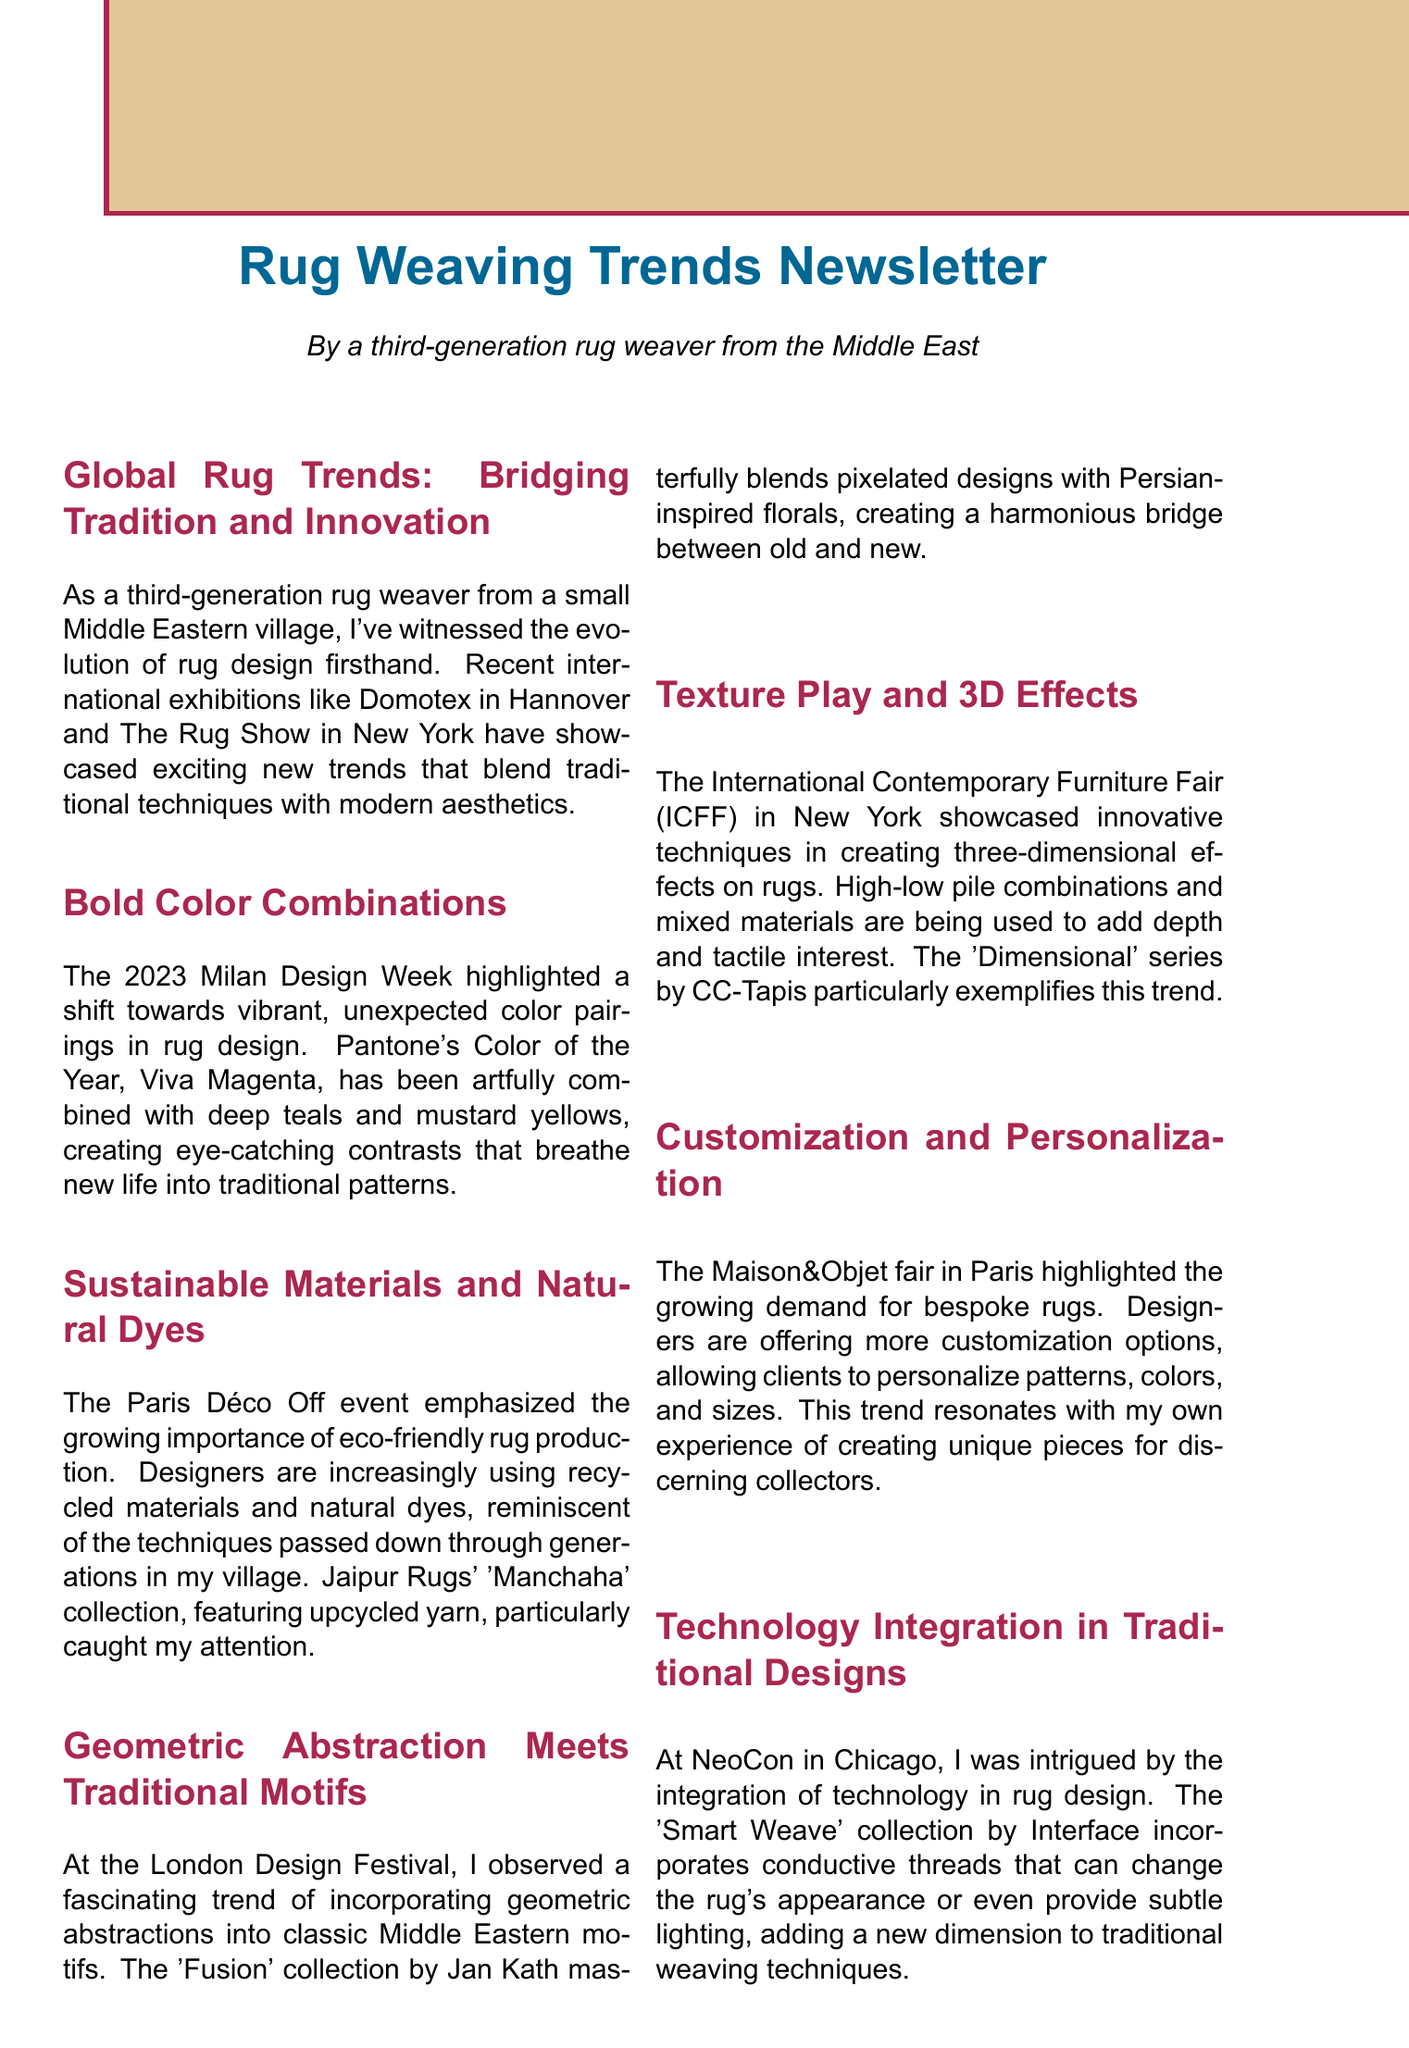what is the title of the first section? The first section is titled "Global Rug Trends: Bridging Tradition and Innovation."
Answer: Global Rug Trends: Bridging Tradition and Innovation what color was named Pantone's Color of the Year for 2023? The document states that Pantone's Color of the Year for 2023 is Viva Magenta.
Answer: Viva Magenta which event emphasized the importance of sustainable materials? The event that emphasized this importance is the Paris Déco Off.
Answer: Paris Déco Off what collection is mentioned for featuring upcycled yarn? The collection mentioned is Jaipur Rugs' 'Manchaha' collection.
Answer: Manchaha what is a notable trend observed at the London Design Festival? A trend observed was incorporating geometric abstractions into classic Middle Eastern motifs.
Answer: Geometric abstractions into classic Middle Eastern motifs how are the customization options described in the document? The document describes customization options as allowing clients to personalize patterns, colors, and sizes.
Answer: Personalize patterns, colors, and sizes what innovative element does the 'Smart Weave' collection include? The 'Smart Weave' collection includes conductive threads.
Answer: Conductive threads what is the primary theme of the conclusion section? The primary theme is embracing change while honoring tradition.
Answer: Embracing change while honoring tradition 